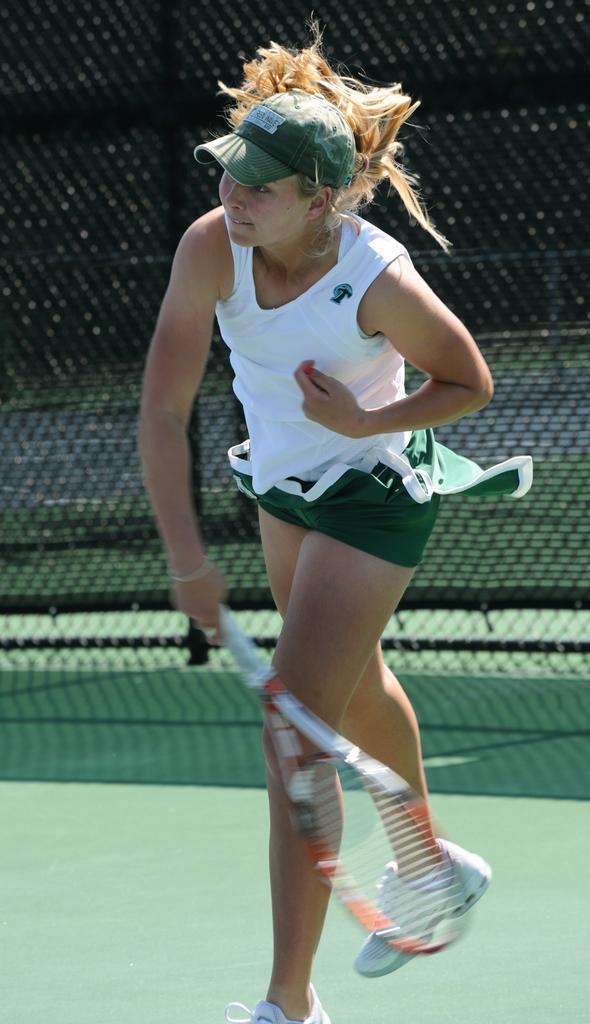Who is present in the image? There is a woman in the image. What is the woman doing in the image? The woman is standing in the image. What object is the woman holding in her hand? The woman is holding a tennis racket in her hand. What is the woman's reaction to the steam in the image? There is no steam present in the image, so the woman's reaction cannot be determined. 